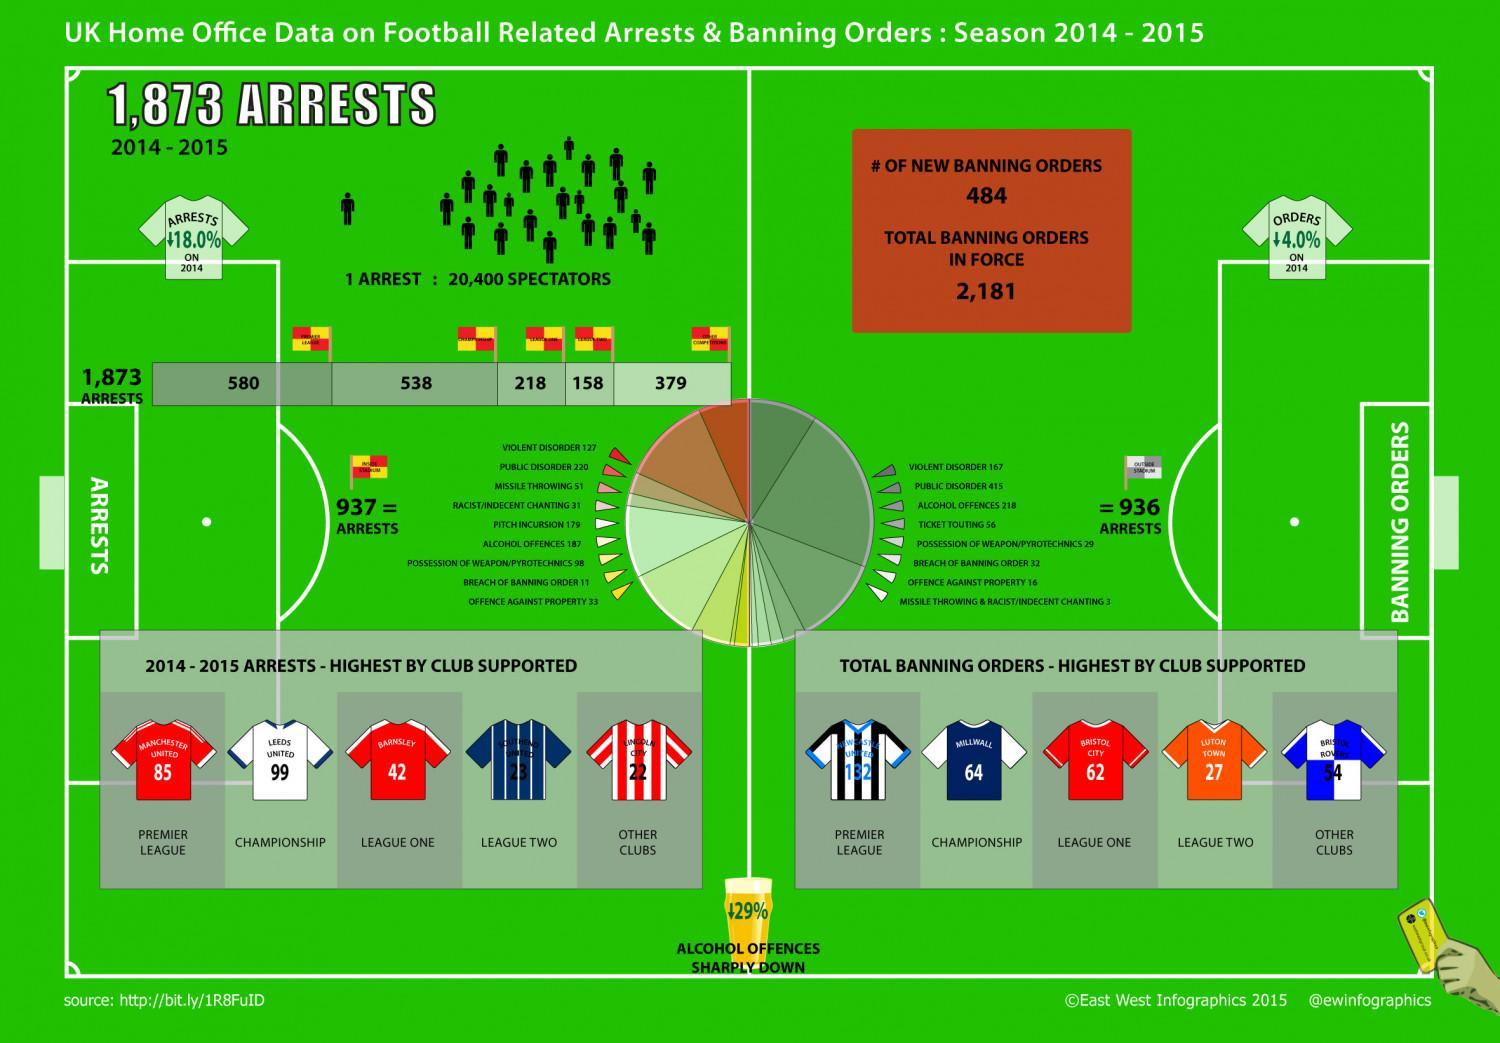During which matches were 64 banning orders issued involving the club Millwall?
Answer the question with a short phrase. Championship Which club was involved in 99 football related arrests recorded during the championship matches 2014-15? Leeds United How many banning orders involving Bristol City during the League One season 2014-15? 62 How many arrests involving Manchester United during the Premier league 2014-15? 85 Alcohol offences have decreased by what percent? 29% 